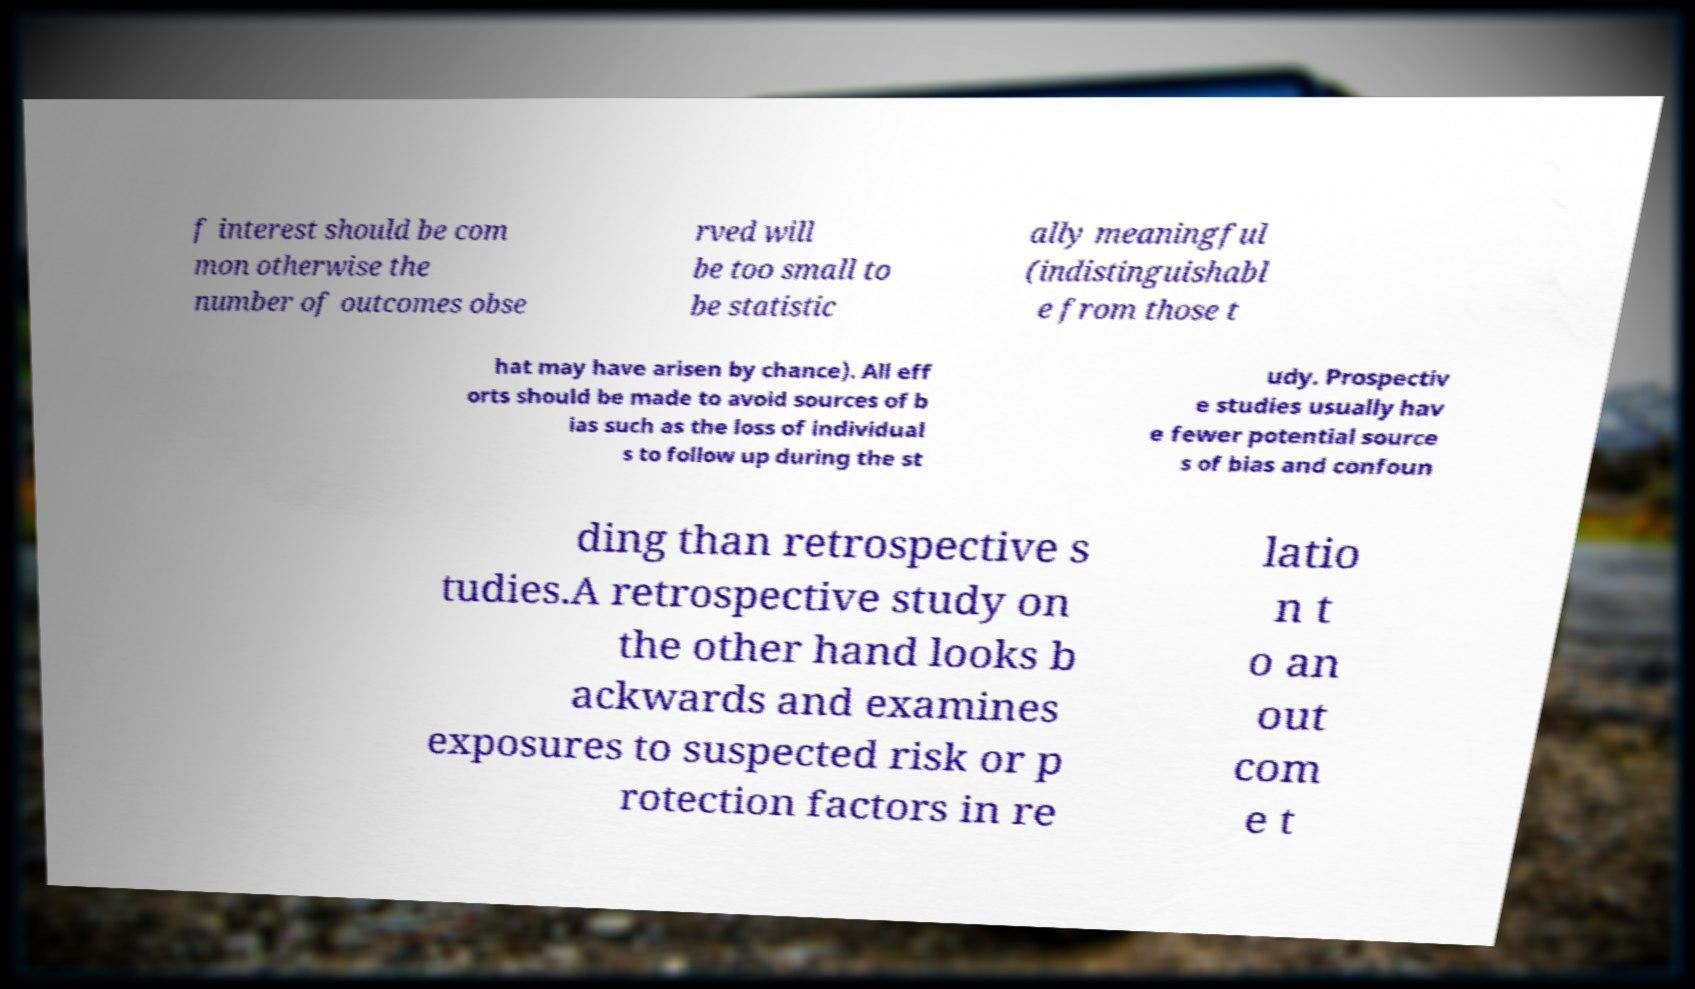Please identify and transcribe the text found in this image. f interest should be com mon otherwise the number of outcomes obse rved will be too small to be statistic ally meaningful (indistinguishabl e from those t hat may have arisen by chance). All eff orts should be made to avoid sources of b ias such as the loss of individual s to follow up during the st udy. Prospectiv e studies usually hav e fewer potential source s of bias and confoun ding than retrospective s tudies.A retrospective study on the other hand looks b ackwards and examines exposures to suspected risk or p rotection factors in re latio n t o an out com e t 